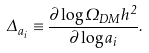<formula> <loc_0><loc_0><loc_500><loc_500>\Delta _ { a _ { i } } \equiv \frac { \partial \log \Omega _ { D M } h ^ { 2 } } { \partial \log a _ { i } } .</formula> 